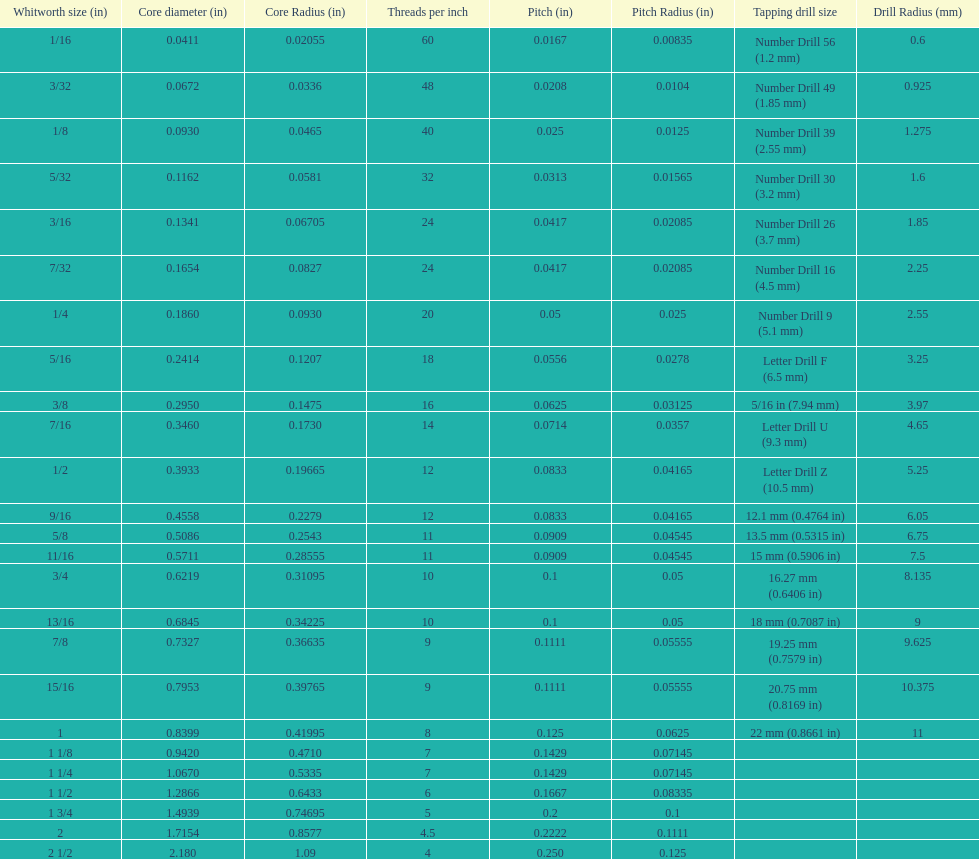What is the subsequent whitworth dimension (in) smaller than 1/8? 5/32. 